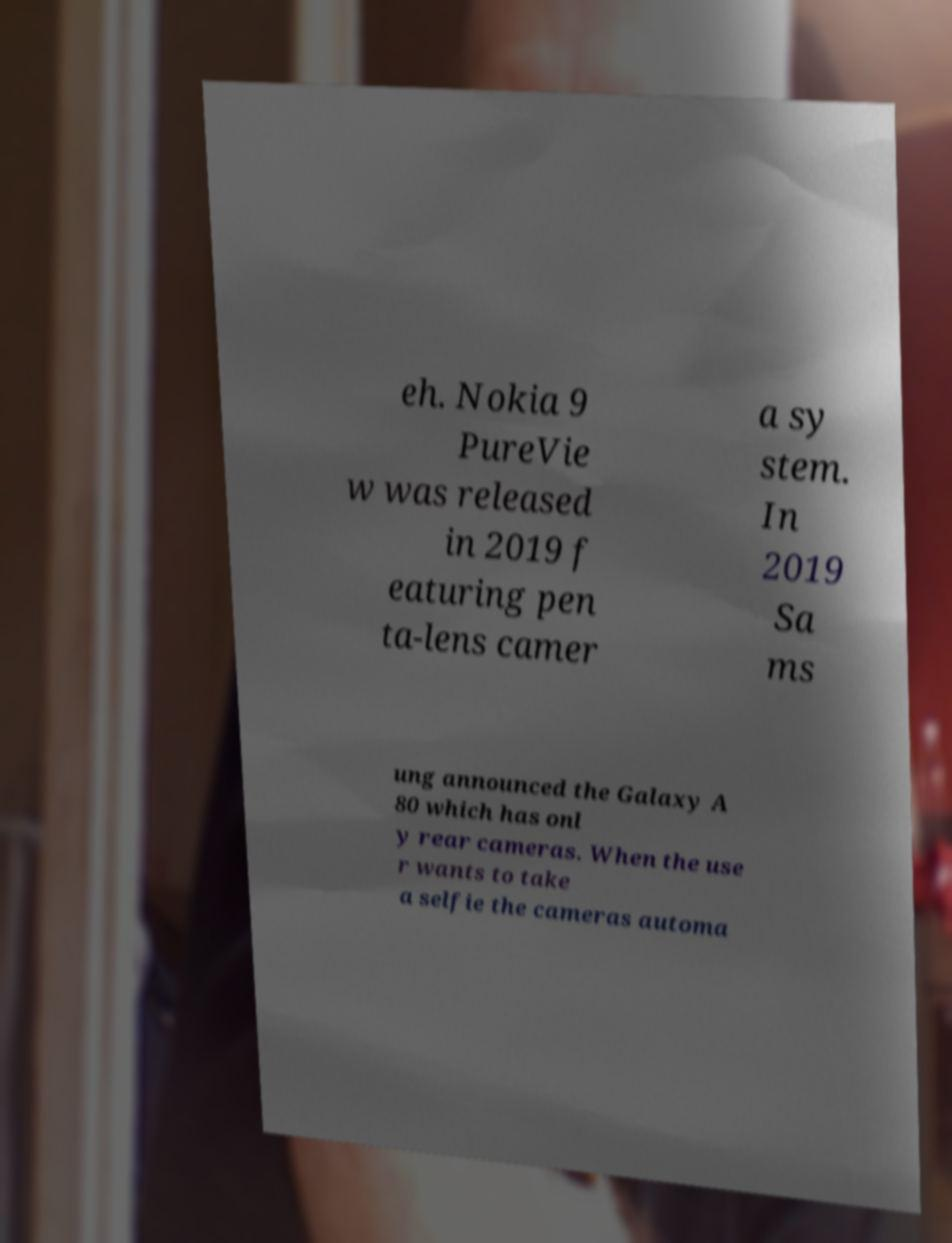What messages or text are displayed in this image? I need them in a readable, typed format. eh. Nokia 9 PureVie w was released in 2019 f eaturing pen ta-lens camer a sy stem. In 2019 Sa ms ung announced the Galaxy A 80 which has onl y rear cameras. When the use r wants to take a selfie the cameras automa 